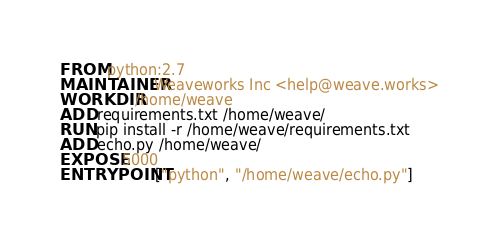<code> <loc_0><loc_0><loc_500><loc_500><_Dockerfile_>FROM python:2.7
MAINTAINER Weaveworks Inc <help@weave.works>
WORKDIR /home/weave
ADD requirements.txt /home/weave/
RUN pip install -r /home/weave/requirements.txt
ADD echo.py /home/weave/
EXPOSE 5000
ENTRYPOINT ["python", "/home/weave/echo.py"]
</code> 